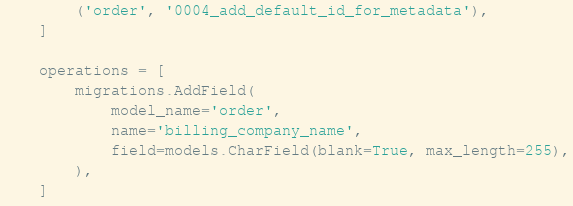<code> <loc_0><loc_0><loc_500><loc_500><_Python_>        ('order', '0004_add_default_id_for_metadata'),
    ]

    operations = [
        migrations.AddField(
            model_name='order',
            name='billing_company_name',
            field=models.CharField(blank=True, max_length=255),
        ),
    ]
</code> 